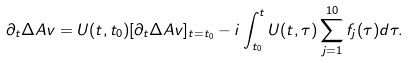Convert formula to latex. <formula><loc_0><loc_0><loc_500><loc_500>\partial _ { t } \Delta A v = U ( t , t _ { 0 } ) [ \partial _ { t } \Delta A v ] _ { t = t _ { 0 } } - i \int _ { t _ { 0 } } ^ { t } U ( t , \tau ) \sum _ { j = 1 } ^ { 1 0 } f _ { j } ( \tau ) d \tau .</formula> 